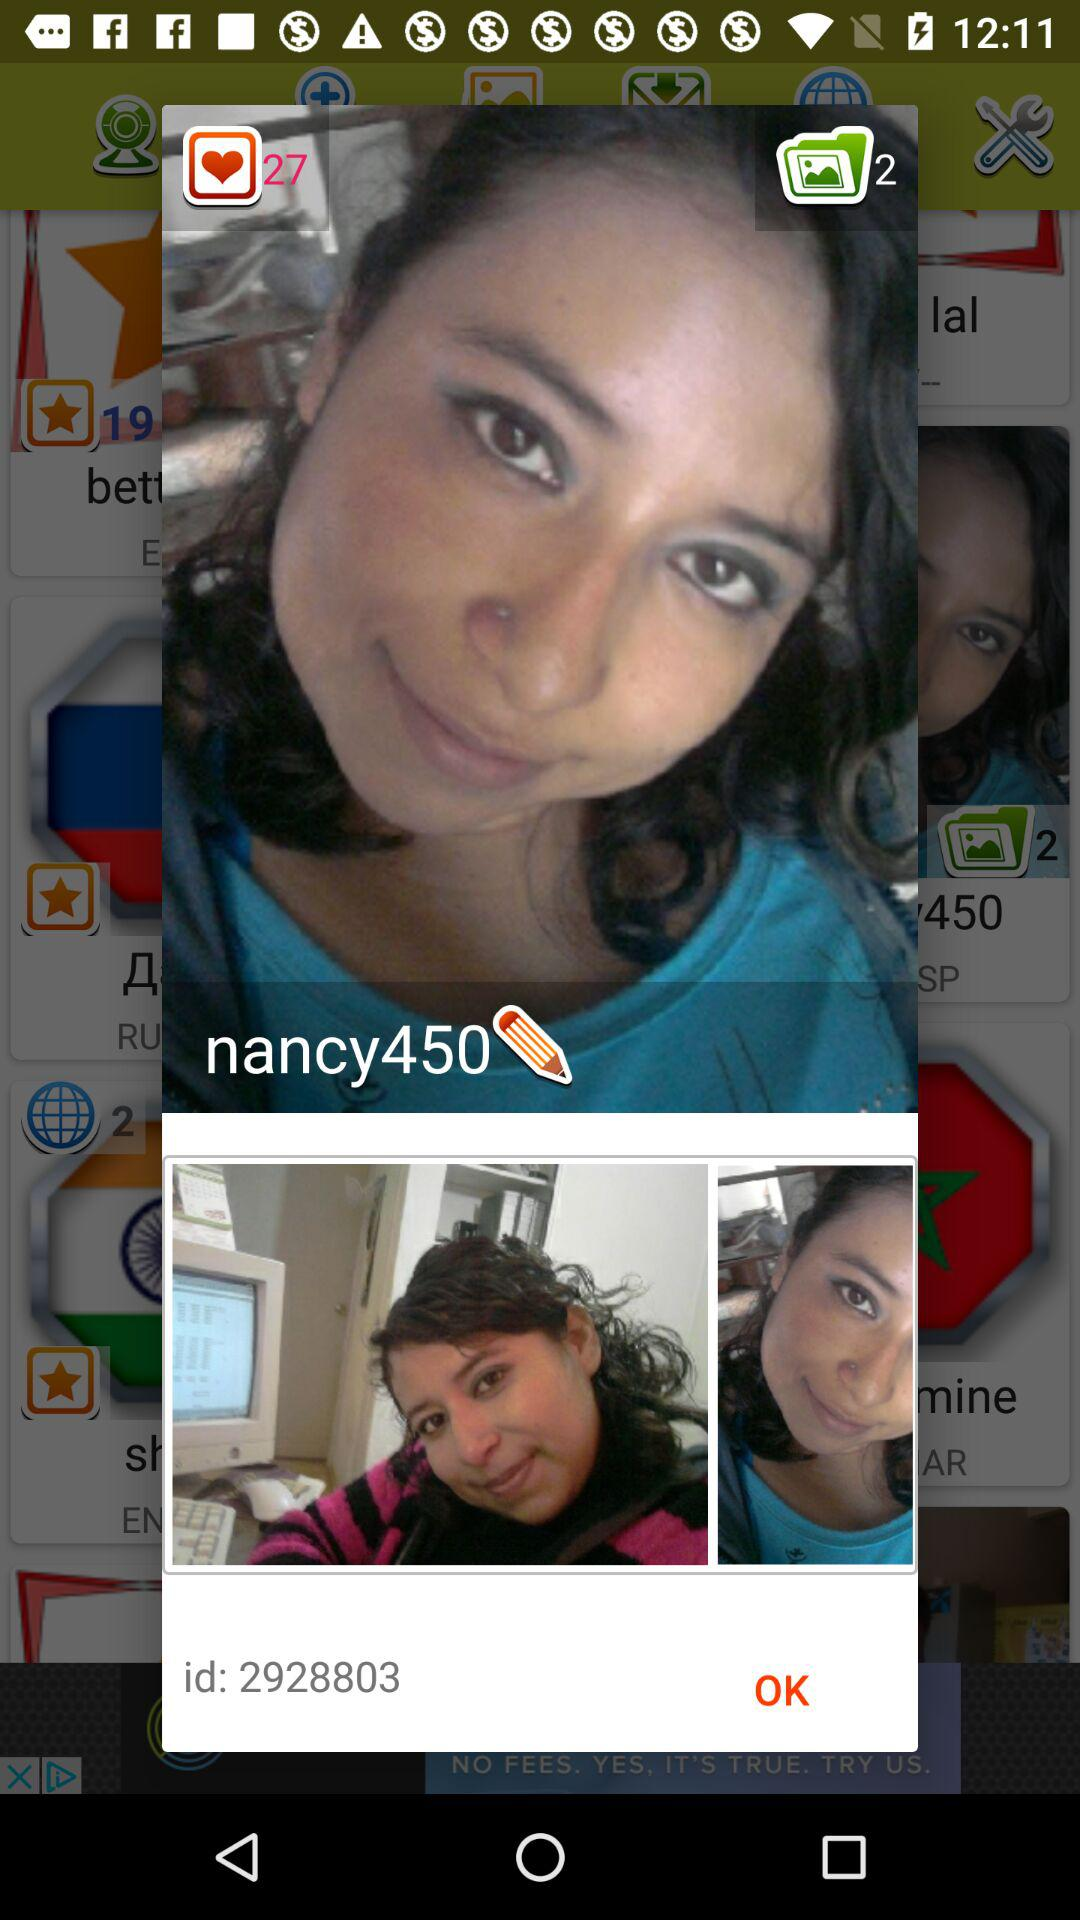What's the user identification number? The user identification number is 2928803. 